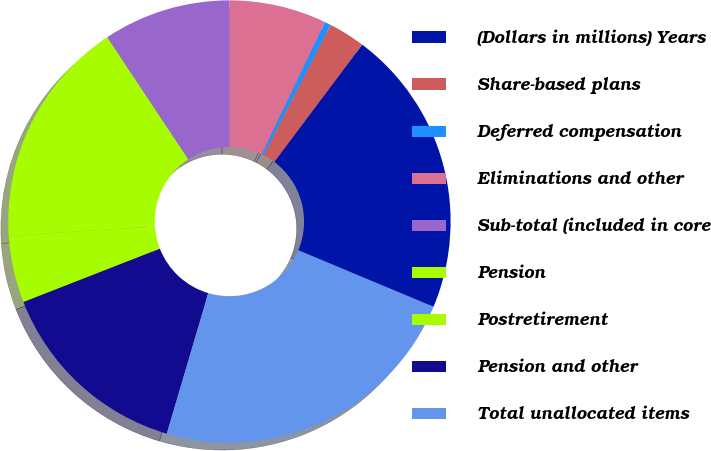<chart> <loc_0><loc_0><loc_500><loc_500><pie_chart><fcel>(Dollars in millions) Years<fcel>Share-based plans<fcel>Deferred compensation<fcel>Eliminations and other<fcel>Sub-total (included in core<fcel>Pension<fcel>Postretirement<fcel>Pension and other<fcel>Total unallocated items<nl><fcel>21.06%<fcel>2.68%<fcel>0.46%<fcel>7.11%<fcel>9.32%<fcel>16.72%<fcel>4.89%<fcel>14.5%<fcel>23.27%<nl></chart> 